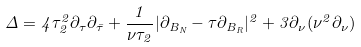<formula> <loc_0><loc_0><loc_500><loc_500>\Delta = 4 \tau _ { 2 } ^ { 2 } \partial _ { \tau } \partial _ { \bar { \tau } } + \frac { 1 } { \nu \tau _ { 2 } } | \partial _ { B _ { N } } - \tau \partial _ { B _ { R } } | ^ { 2 } + 3 \partial _ { \nu } ( \nu ^ { 2 } \partial _ { \nu } )</formula> 